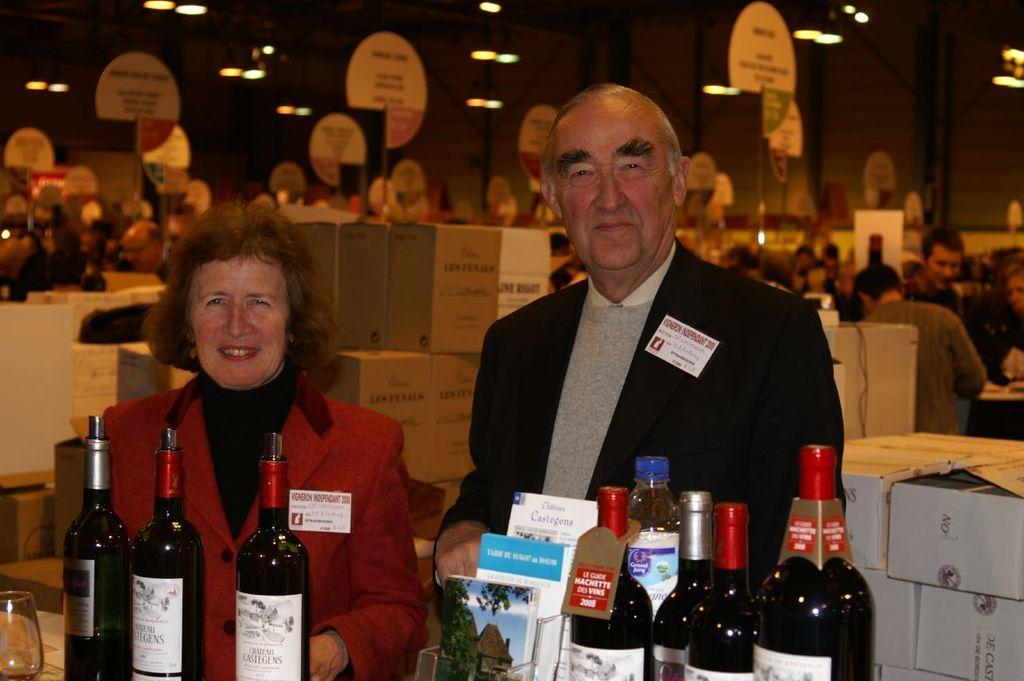In one or two sentences, can you explain what this image depicts? In this pictures there is a woman and a man smiling and there are many wine bottles in front of them. 